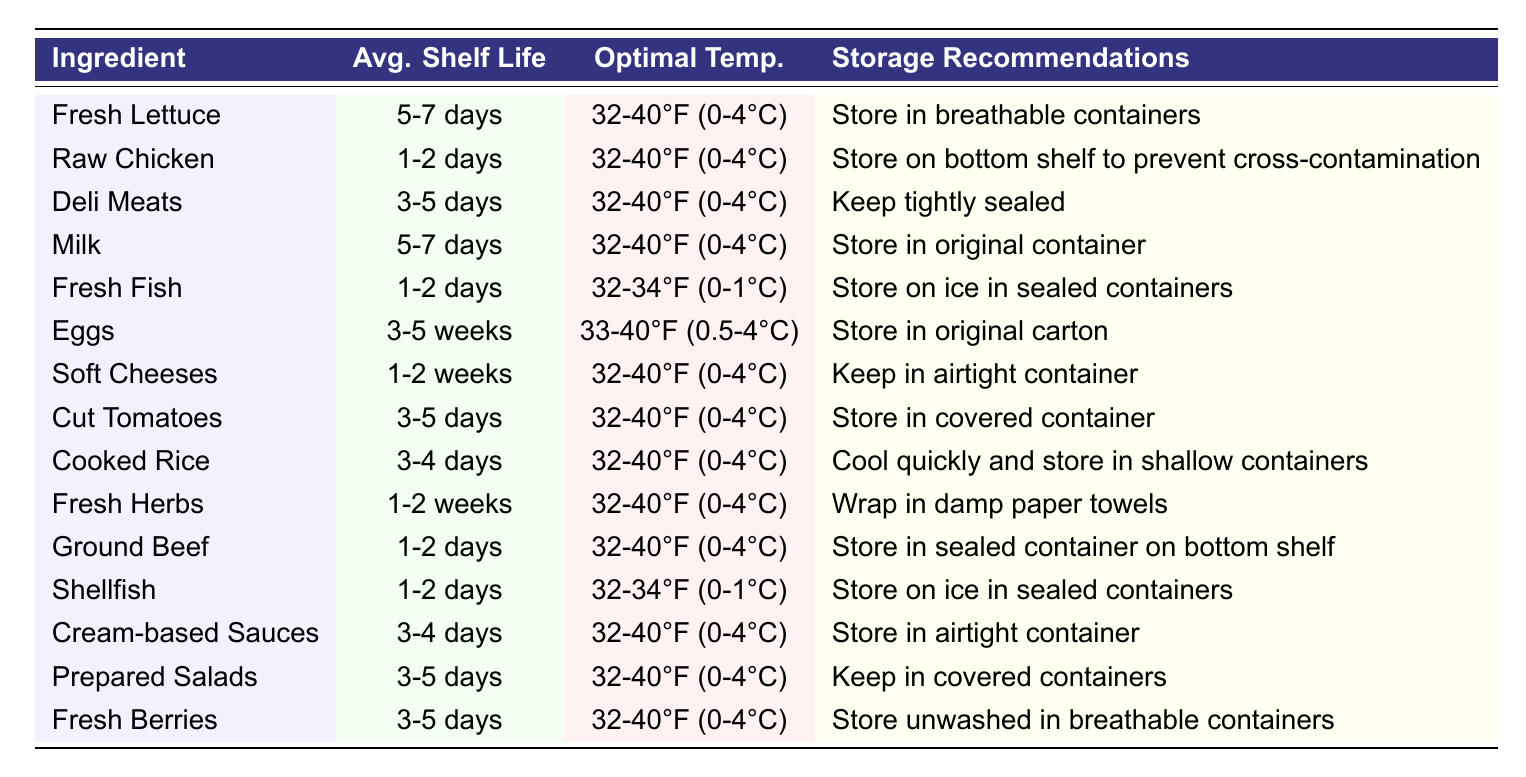What is the average shelf life of eggs? The table states that the average shelf life of eggs is categorized as 3-5 weeks.
Answer: 3-5 weeks Which ingredient has the shortest average shelf life? The shortest average shelf life is found for raw chicken, fresh fish, ground beef, deli meats, and shellfish, all with an average shelf life of 1-2 days.
Answer: Raw chicken, fresh fish, ground beef, deli meats, and shellfish (1-2 days) Is fresh berries stored unwashed in breathable containers? Yes, the table specifies that fresh berries should be stored unwashed in breathable containers.
Answer: Yes What is the optimal storage temperature range for most ingredients listed? The optimal storage temperature for most ingredients, according to the table, is 32-40°F (0-4°C), except for fresh fish and shellfish which have a slightly colder range.
Answer: 32-40°F (0-4°C) How many ingredients have a shelf life of more than 1 week? By examining the table, eggs (3-5 weeks), soft cheeses (1-2 weeks), fresh herbs (1-2 weeks), and cooked rice (3-4 days) exceed a shelf life of one week. This totals four ingredients.
Answer: 4 ingredients If you wanted to store fresh fish properly, what would you do? The table recommends storing fresh fish on ice in sealed containers to maintain its freshness.
Answer: Store on ice in sealed containers Which ingredient requires storage on the bottom shelf to prevent cross-contamination? The table indicates that raw chicken should be stored on the bottom shelf to prevent cross-contamination.
Answer: Raw chicken What is the difference in average shelf life between eggs and fresh fish? Eggs have an average shelf life of 3-5 weeks, while fresh fish is 1-2 days. The difference is 3-5 weeks (21-35 days) versus 1-2 days (1-2 days). This gives us a significant difference of about 20-34 days.
Answer: 20-34 days Are soft cheeses and prepared salads stored in airtight containers? Soft cheeses are stored in airtight containers, but prepared salads are kept in covered containers. So only soft cheeses meet this condition.
Answer: No Which ingredient has the same storage recommendation as cream-based sauces? The storage recommendation for cream-based sauces is to store them in an airtight container, and this is also true for soft cheeses.
Answer: Soft cheeses 